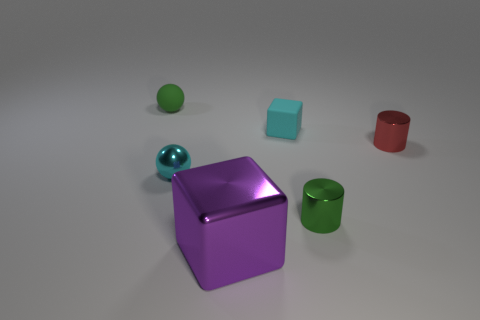What number of tiny things are purple metal blocks or shiny things?
Offer a very short reply. 3. Are there more small green spheres than large gray metallic cylinders?
Offer a very short reply. Yes. Is the large purple thing made of the same material as the small red object?
Keep it short and to the point. Yes. Are there more metal objects that are behind the purple shiny cube than large shiny cubes?
Make the answer very short. Yes. Is the small block the same color as the tiny metal ball?
Offer a very short reply. Yes. How many small cyan things are the same shape as the purple object?
Give a very brief answer. 1. What is the size of the green cylinder that is the same material as the large thing?
Provide a succinct answer. Small. What is the color of the thing that is behind the red metal cylinder and on the right side of the metal ball?
Give a very brief answer. Cyan. How many matte spheres have the same size as the purple metallic cube?
Ensure brevity in your answer.  0. What is the size of the object that is both behind the small cyan ball and to the right of the tiny cyan rubber cube?
Your response must be concise. Small. 